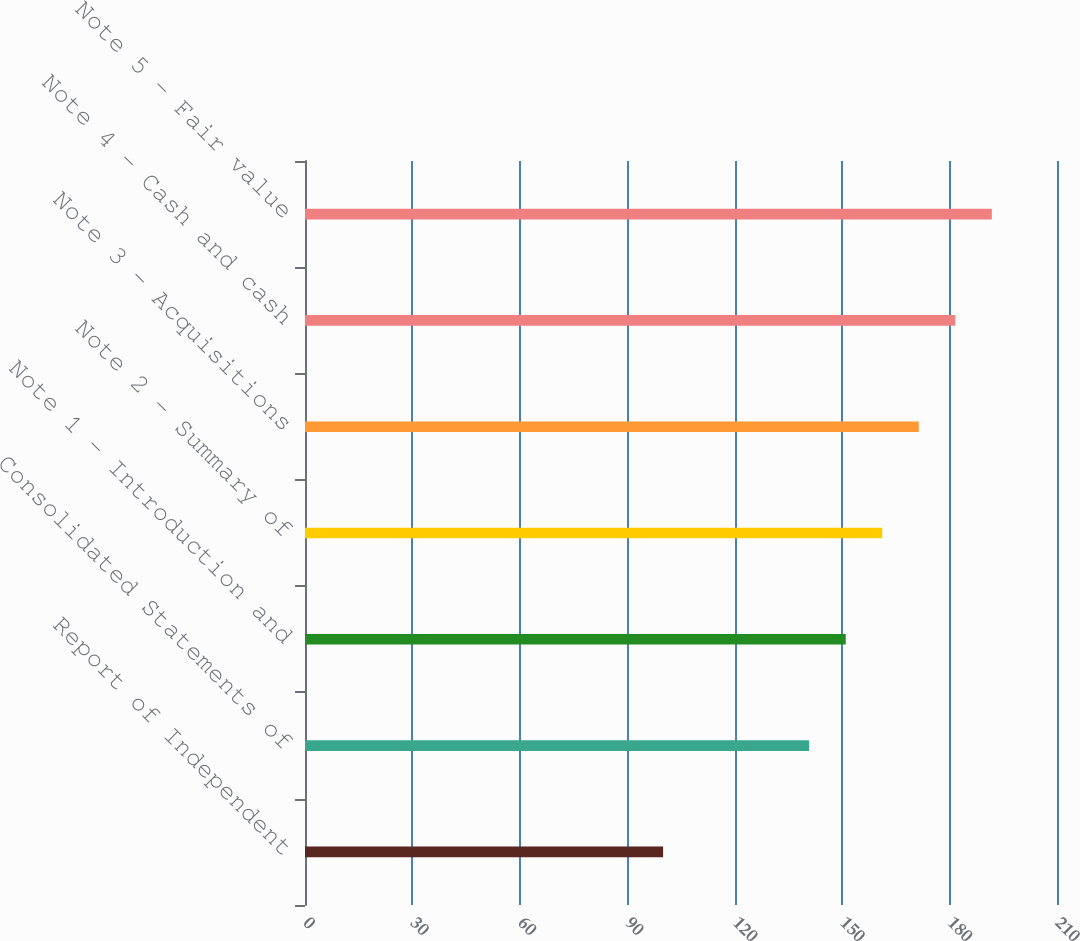Convert chart. <chart><loc_0><loc_0><loc_500><loc_500><bar_chart><fcel>Report of Independent<fcel>Consolidated Statements of<fcel>Note 1 - Introduction and<fcel>Note 2 - Summary of<fcel>Note 3 - Acquisitions<fcel>Note 4 - Cash and cash<fcel>Note 5 - Fair value<nl><fcel>100<fcel>140.8<fcel>151<fcel>161.2<fcel>171.4<fcel>181.6<fcel>191.8<nl></chart> 